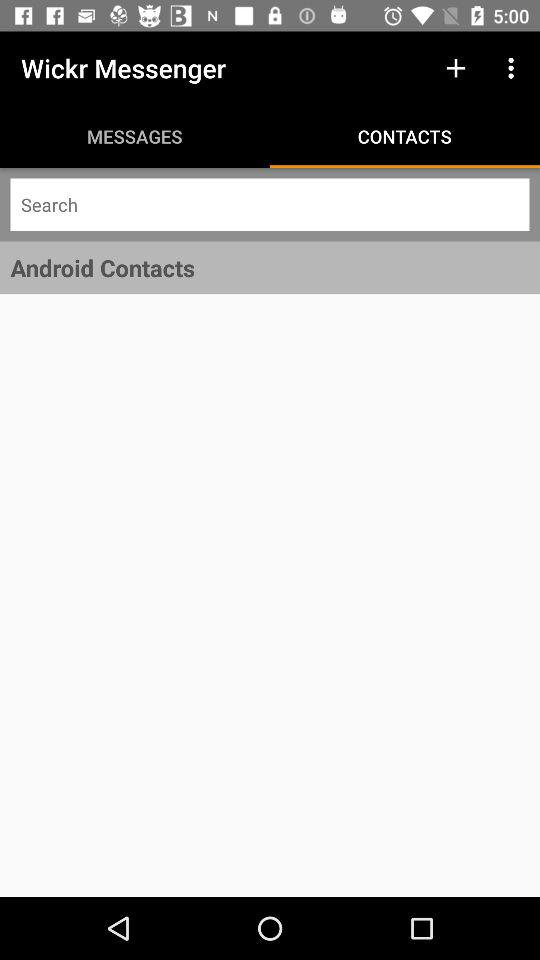Which tab is selected? The selected tab is "CONTACTS". 